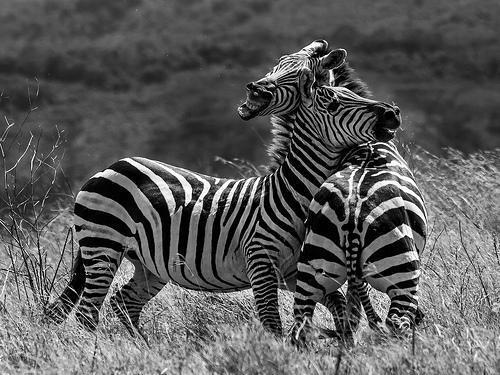How many animals are in the picture?
Give a very brief answer. 2. 